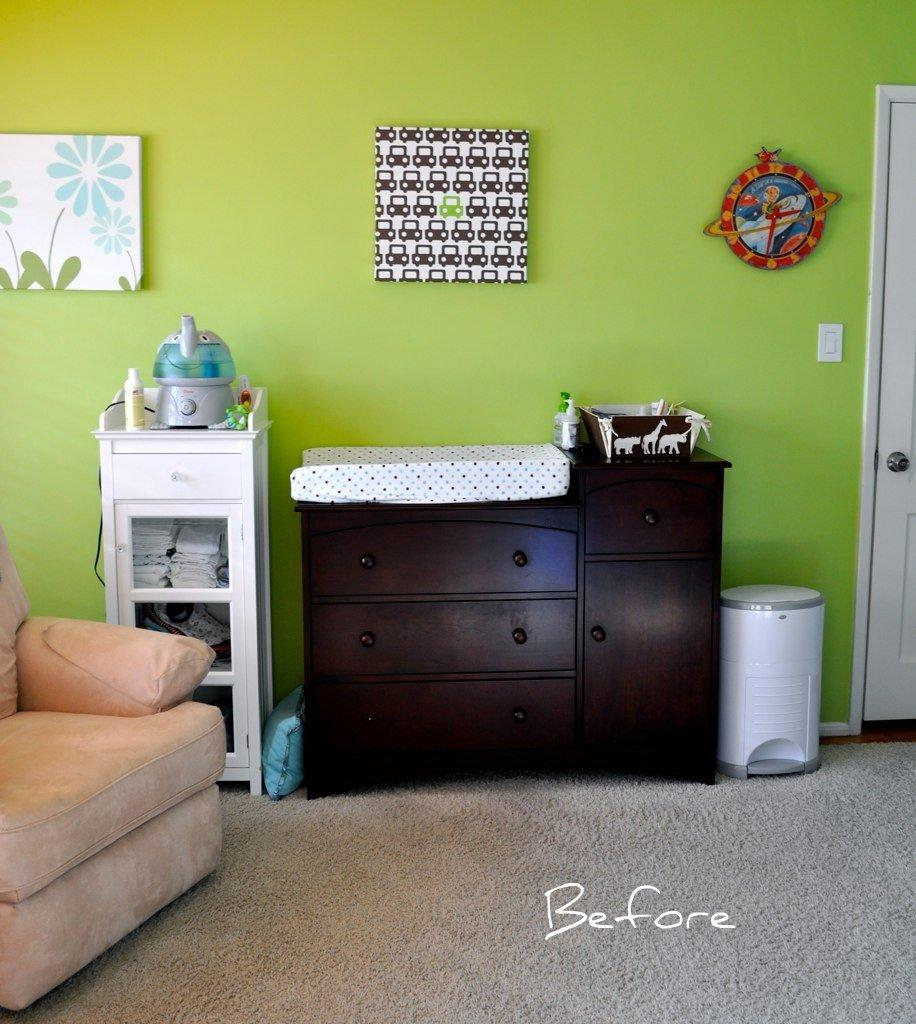<image>
Relay a brief, clear account of the picture shown. room with chair, case with diapers visible, humidifier, dresser with cloth on top, trash can, etc and the word before showing dirty side of carpet compared to other side 